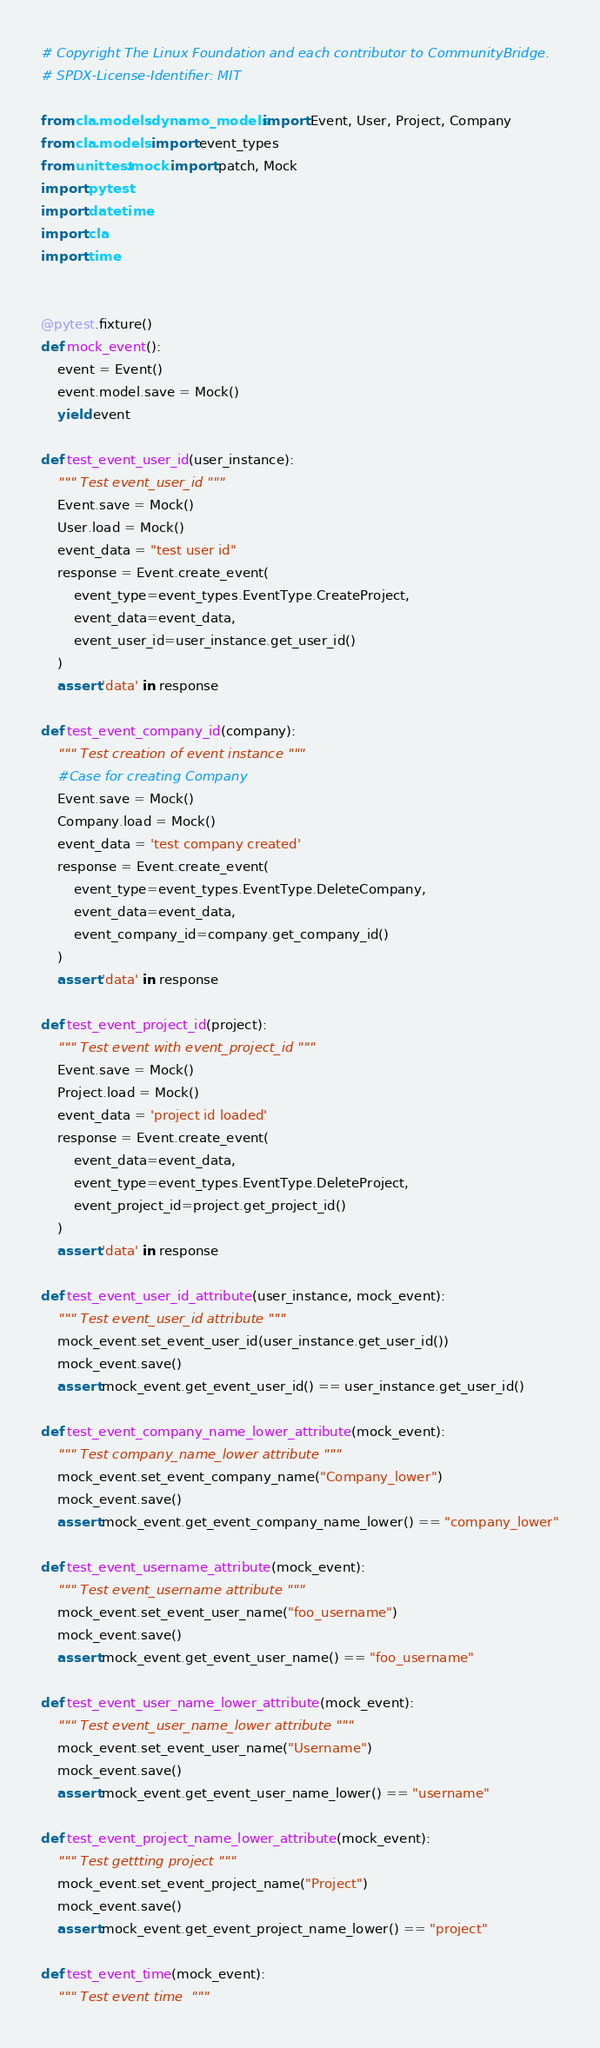<code> <loc_0><loc_0><loc_500><loc_500><_Python_># Copyright The Linux Foundation and each contributor to CommunityBridge.
# SPDX-License-Identifier: MIT

from cla.models.dynamo_models import Event, User, Project, Company
from cla.models import event_types
from unittest.mock import patch, Mock
import pytest
import datetime
import cla
import time


@pytest.fixture()
def mock_event():
    event = Event()
    event.model.save = Mock()
    yield event

def test_event_user_id(user_instance):
    """ Test event_user_id """
    Event.save = Mock()
    User.load = Mock()
    event_data = "test user id"
    response = Event.create_event(
        event_type=event_types.EventType.CreateProject,
        event_data=event_data,
        event_user_id=user_instance.get_user_id()
    )
    assert 'data' in response

def test_event_company_id(company):
    """ Test creation of event instance """
    #Case for creating Company
    Event.save = Mock()
    Company.load = Mock()
    event_data = 'test company created'
    response = Event.create_event(
        event_type=event_types.EventType.DeleteCompany,
        event_data=event_data,
        event_company_id=company.get_company_id()
    )
    assert 'data' in response

def test_event_project_id(project):
    """ Test event with event_project_id """
    Event.save = Mock()
    Project.load = Mock()
    event_data = 'project id loaded'
    response = Event.create_event(
        event_data=event_data,
        event_type=event_types.EventType.DeleteProject,
        event_project_id=project.get_project_id()
    )
    assert 'data' in response

def test_event_user_id_attribute(user_instance, mock_event):
    """ Test event_user_id attribute """
    mock_event.set_event_user_id(user_instance.get_user_id())
    mock_event.save()
    assert mock_event.get_event_user_id() == user_instance.get_user_id()

def test_event_company_name_lower_attribute(mock_event):
    """ Test company_name_lower attribute """
    mock_event.set_event_company_name("Company_lower")
    mock_event.save()
    assert mock_event.get_event_company_name_lower() == "company_lower"

def test_event_username_attribute(mock_event):
    """ Test event_username attribute """
    mock_event.set_event_user_name("foo_username")
    mock_event.save()
    assert mock_event.get_event_user_name() == "foo_username"

def test_event_user_name_lower_attribute(mock_event):
    """ Test event_user_name_lower attribute """
    mock_event.set_event_user_name("Username")
    mock_event.save()
    assert mock_event.get_event_user_name_lower() == "username"

def test_event_project_name_lower_attribute(mock_event):
    """ Test gettting project """
    mock_event.set_event_project_name("Project")
    mock_event.save()
    assert mock_event.get_event_project_name_lower() == "project"

def test_event_time(mock_event):
    """ Test event time  """</code> 